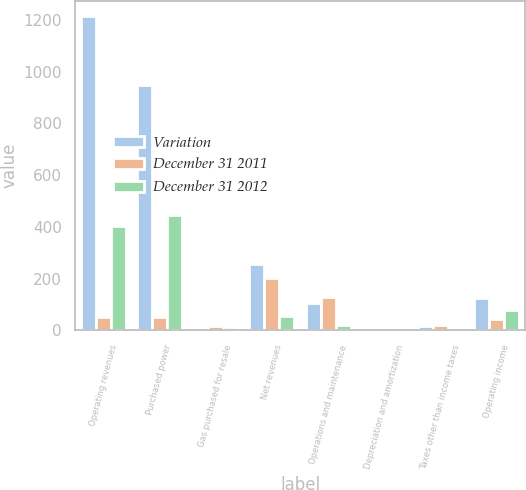<chart> <loc_0><loc_0><loc_500><loc_500><stacked_bar_chart><ecel><fcel>Operating revenues<fcel>Purchased power<fcel>Gas purchased for resale<fcel>Net revenues<fcel>Operations and maintenance<fcel>Depreciation and amortization<fcel>Taxes other than income taxes<fcel>Operating income<nl><fcel>Variation<fcel>1213<fcel>950<fcel>5<fcel>258<fcel>107<fcel>8<fcel>18<fcel>125<nl><fcel>December 31 2011<fcel>51<fcel>51<fcel>18<fcel>202<fcel>128<fcel>7<fcel>21<fcel>46<nl><fcel>December 31 2012<fcel>404<fcel>447<fcel>13<fcel>56<fcel>21<fcel>1<fcel>3<fcel>79<nl></chart> 